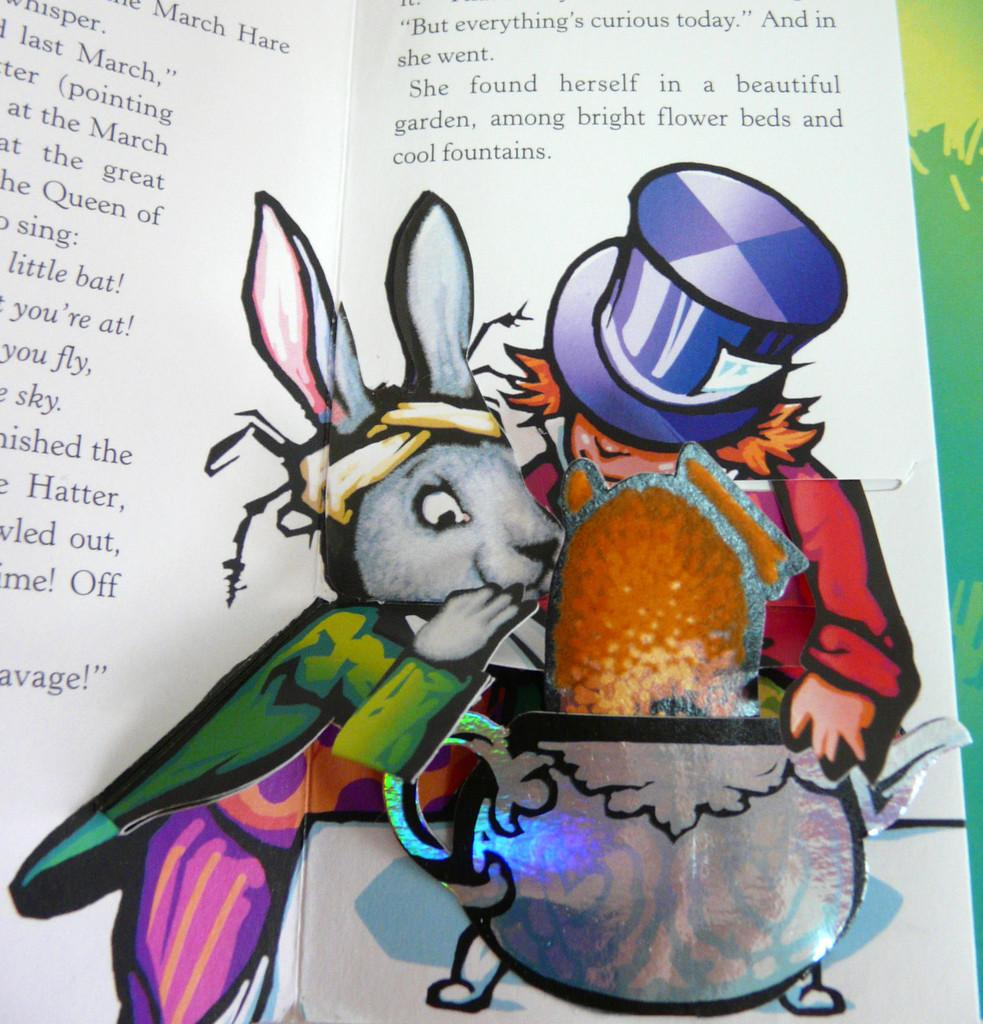What is the main subject of the image? The main subject of the image is an open book. What can be found inside the open book? The open book contains letters, a picture of a mouse, a picture of a pot, and a picture of a person. Can you describe the pictures inside the open book? Yes, there is a picture of a mouse, a picture of a pot, and a picture of a person. What type of steam can be seen coming from the back of the book in the image? There is no steam present in the image; it features an open book with letters and pictures. 